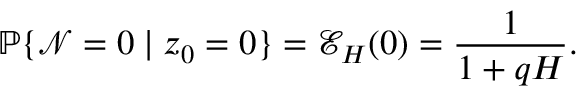<formula> <loc_0><loc_0><loc_500><loc_500>\mathbb { P } \{ \mathcal { N } = 0 | z _ { 0 } = 0 \} = \mathcal { E } _ { H } ( 0 ) = \frac { 1 } { 1 + q H } .</formula> 